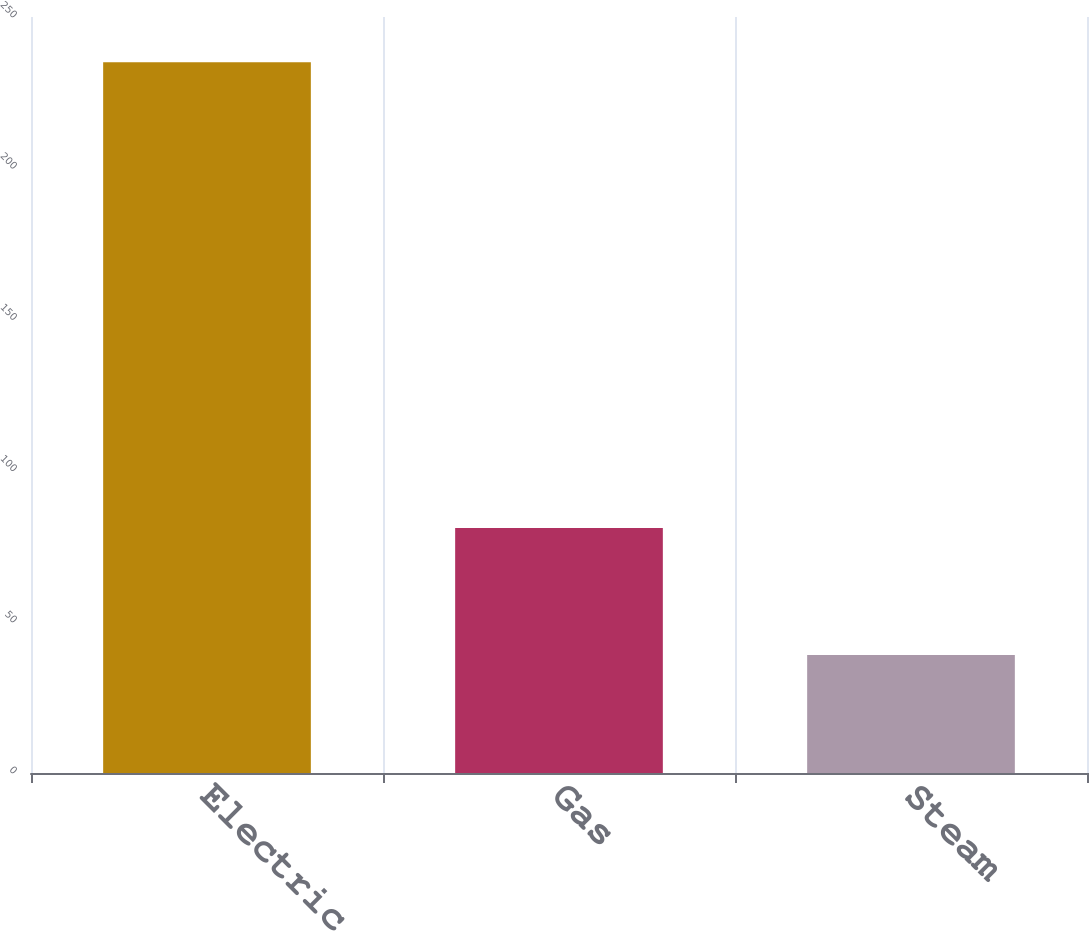Convert chart to OTSL. <chart><loc_0><loc_0><loc_500><loc_500><bar_chart><fcel>Electric<fcel>Gas<fcel>Steam<nl><fcel>235<fcel>81<fcel>39<nl></chart> 